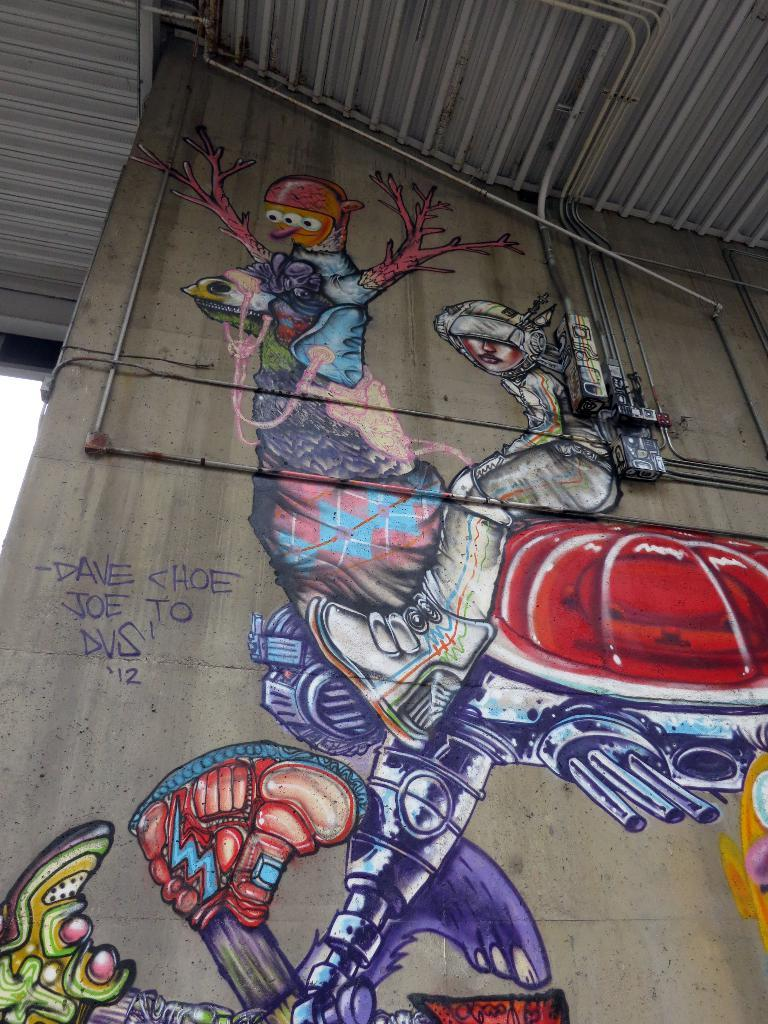What is depicted on the wall in the image? There are paintings on the wall in the image. What else can be seen on the wall besides the paintings? There are pipes on the wall in the image. What is visible at the top of the image? There is a roof visible at the top of the image. How many chickens are present in the image? There are no chickens present in the image. What is the relationship between the two sisters in the image? There is no mention of any sisters in the image. 